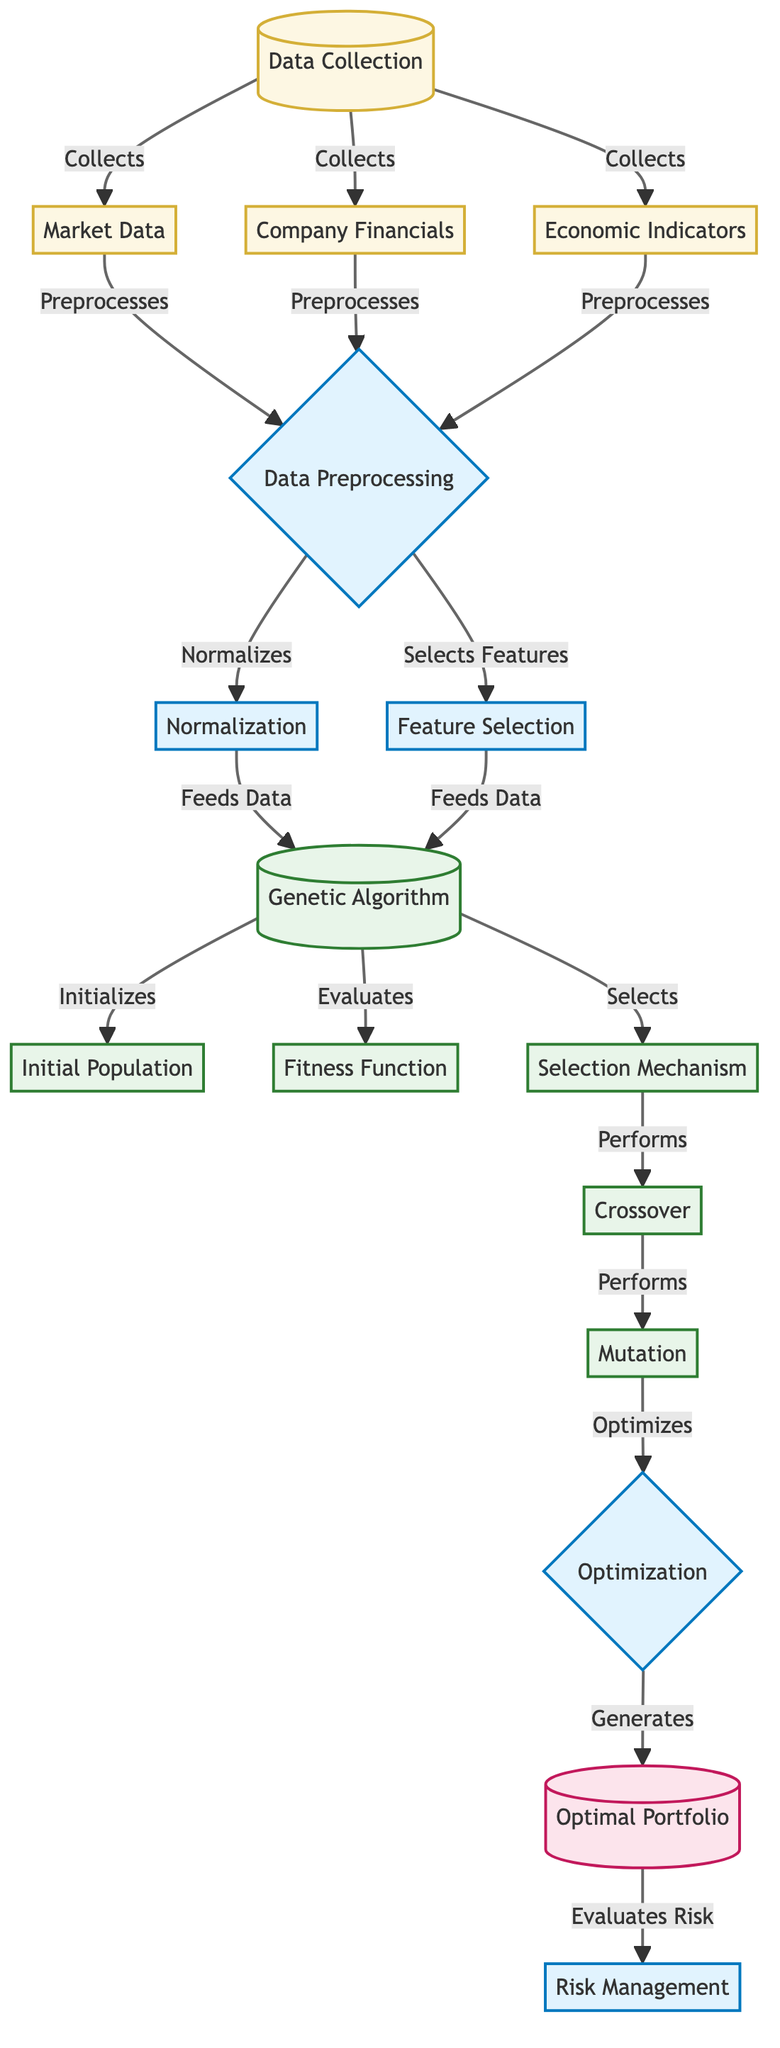What nodes are involved in data collection? The nodes involved in data collection are Market Data, Company Financials, and Economic Indicators, which are all connected to the Data Collection node.
Answer: Market Data, Company Financials, Economic Indicators How many processes are there in the diagram? The processes in the diagram are Data Preprocessing, Normalization, Feature Selection, Optimization, and Risk Management. Counting these gives a total of five processes.
Answer: 5 Which node immediately follows the Genetic Algorithm node? The node that immediately follows the Genetic Algorithm node is Initial Population. This can be seen from the direct connection in the flow of the diagram.
Answer: Initial Population What is the output of the Genetic Algorithm node? The output of the Genetic Algorithm node is the Optimal Portfolio, as indicated by the arrow flowing from Genetic Algorithm to Optimal Portfolio.
Answer: Optimal Portfolio What is the role of the Mutation node? The Mutation node performs optimization, which means it is part of the iterative process to enhance the asset allocation in the Genetic Algorithm.
Answer: Optimizes How does the data preprocessing stage connect to the normalization and feature selection steps? Data Preprocessing leads to both Normalization and Feature Selection, indicating that this stage prepares data for these two subsequent steps in parallel.
Answer: Preprocesses What is the purpose of the Fitness Function node in the process? The Fitness Function evaluates the population based on how well it meets the defined investment objectives, which is a crucial part of the optimization process.
Answer: Evaluates Which nodes are fed into the Genetic Algorithm? The Genetic Algorithm is fed data from Normalization and Feature Selection, meaning these steps process the data before it is utilized for the algorithm.
Answer: Normalization, Feature Selection What does the Risk Management node do after receiving the Optimal Portfolio? The Risk Management node evaluates the risk associated with the Optimal Portfolio, which is the final step in ensuring the portfolio aligns with risk tolerance levels.
Answer: Evaluates Risk 